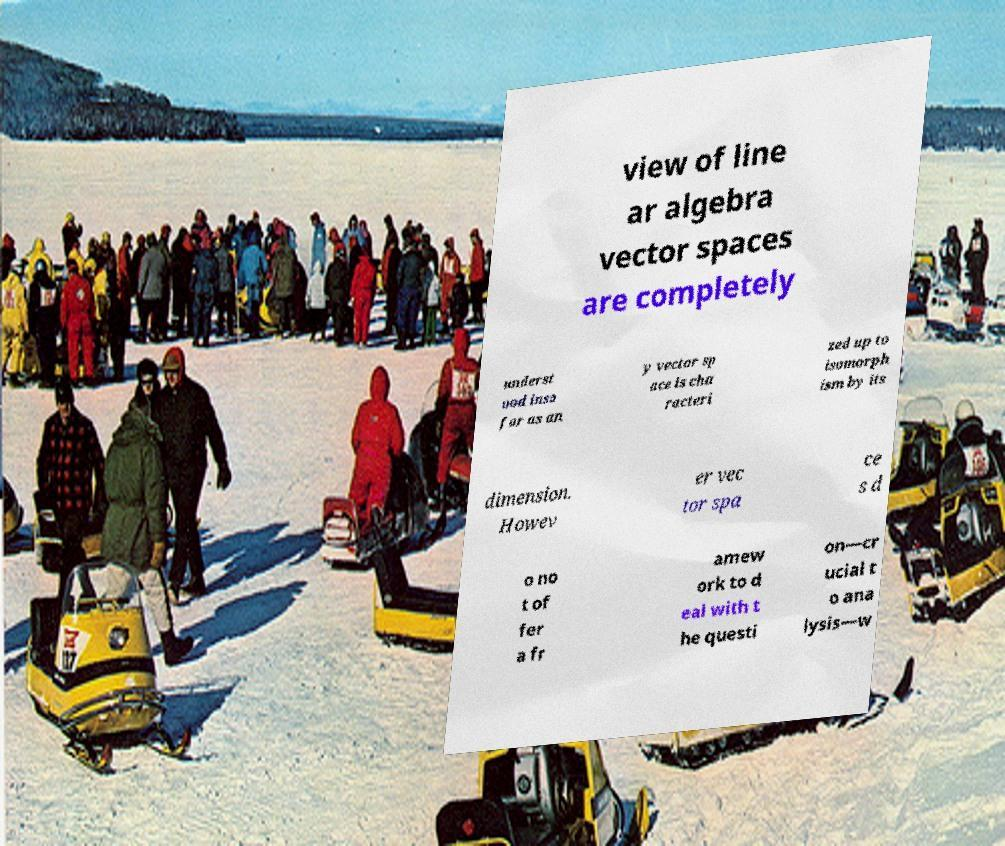Could you assist in decoding the text presented in this image and type it out clearly? view of line ar algebra vector spaces are completely underst ood inso far as an y vector sp ace is cha racteri zed up to isomorph ism by its dimension. Howev er vec tor spa ce s d o no t of fer a fr amew ork to d eal with t he questi on—cr ucial t o ana lysis—w 